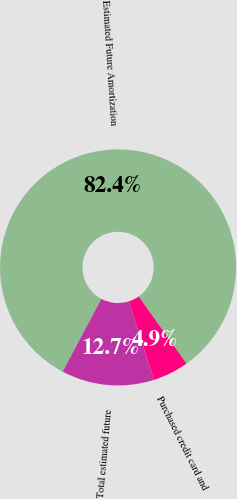Convert chart to OTSL. <chart><loc_0><loc_0><loc_500><loc_500><pie_chart><fcel>Estimated Future Amortization<fcel>Purchased credit card and<fcel>Total estimated future<nl><fcel>82.38%<fcel>4.94%<fcel>12.68%<nl></chart> 